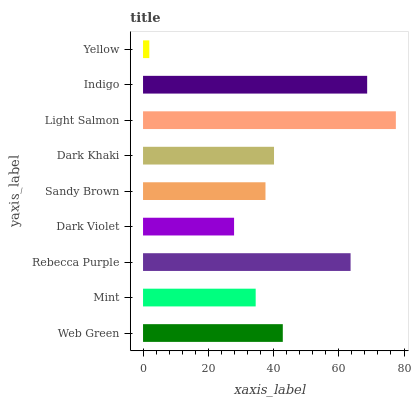Is Yellow the minimum?
Answer yes or no. Yes. Is Light Salmon the maximum?
Answer yes or no. Yes. Is Mint the minimum?
Answer yes or no. No. Is Mint the maximum?
Answer yes or no. No. Is Web Green greater than Mint?
Answer yes or no. Yes. Is Mint less than Web Green?
Answer yes or no. Yes. Is Mint greater than Web Green?
Answer yes or no. No. Is Web Green less than Mint?
Answer yes or no. No. Is Dark Khaki the high median?
Answer yes or no. Yes. Is Dark Khaki the low median?
Answer yes or no. Yes. Is Dark Violet the high median?
Answer yes or no. No. Is Yellow the low median?
Answer yes or no. No. 